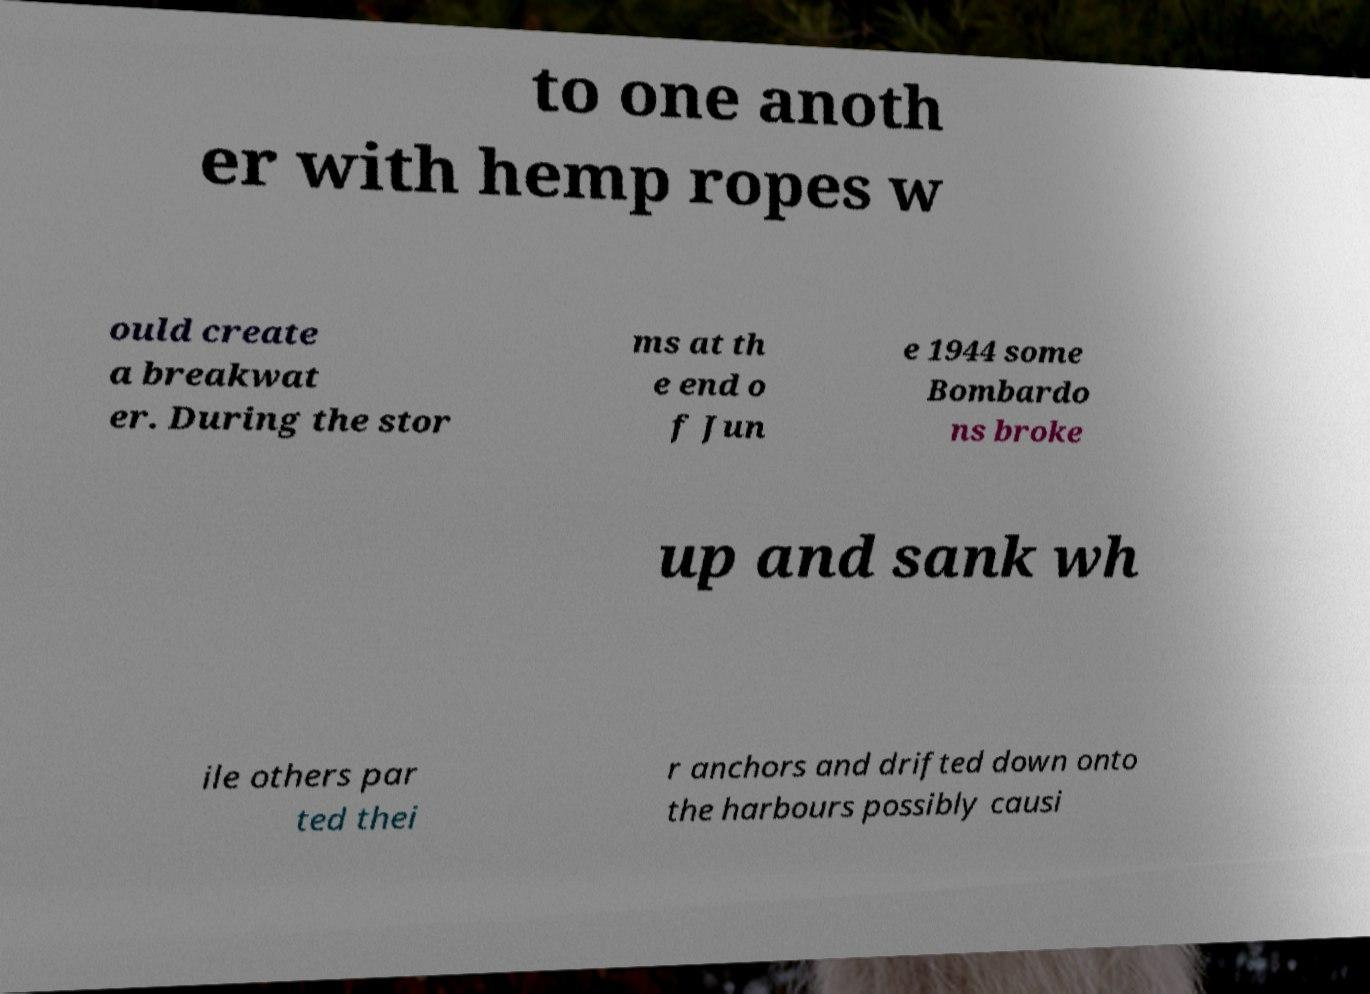For documentation purposes, I need the text within this image transcribed. Could you provide that? to one anoth er with hemp ropes w ould create a breakwat er. During the stor ms at th e end o f Jun e 1944 some Bombardo ns broke up and sank wh ile others par ted thei r anchors and drifted down onto the harbours possibly causi 